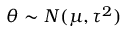Convert formula to latex. <formula><loc_0><loc_0><loc_500><loc_500>\theta \sim N ( \mu , \tau ^ { 2 } )</formula> 